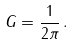<formula> <loc_0><loc_0><loc_500><loc_500>G = \frac { 1 } { 2 \pi } \, .</formula> 